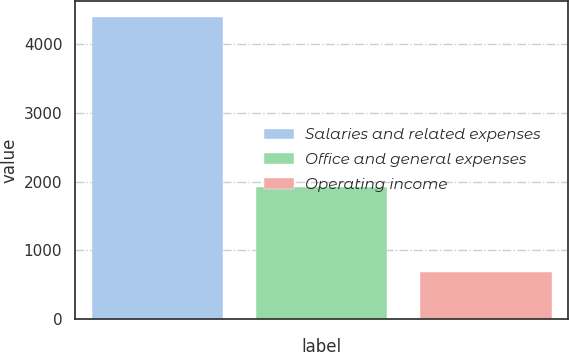Convert chart to OTSL. <chart><loc_0><loc_0><loc_500><loc_500><bar_chart><fcel>Salaries and related expenses<fcel>Office and general expenses<fcel>Operating income<nl><fcel>4402.1<fcel>1925.3<fcel>687.2<nl></chart> 